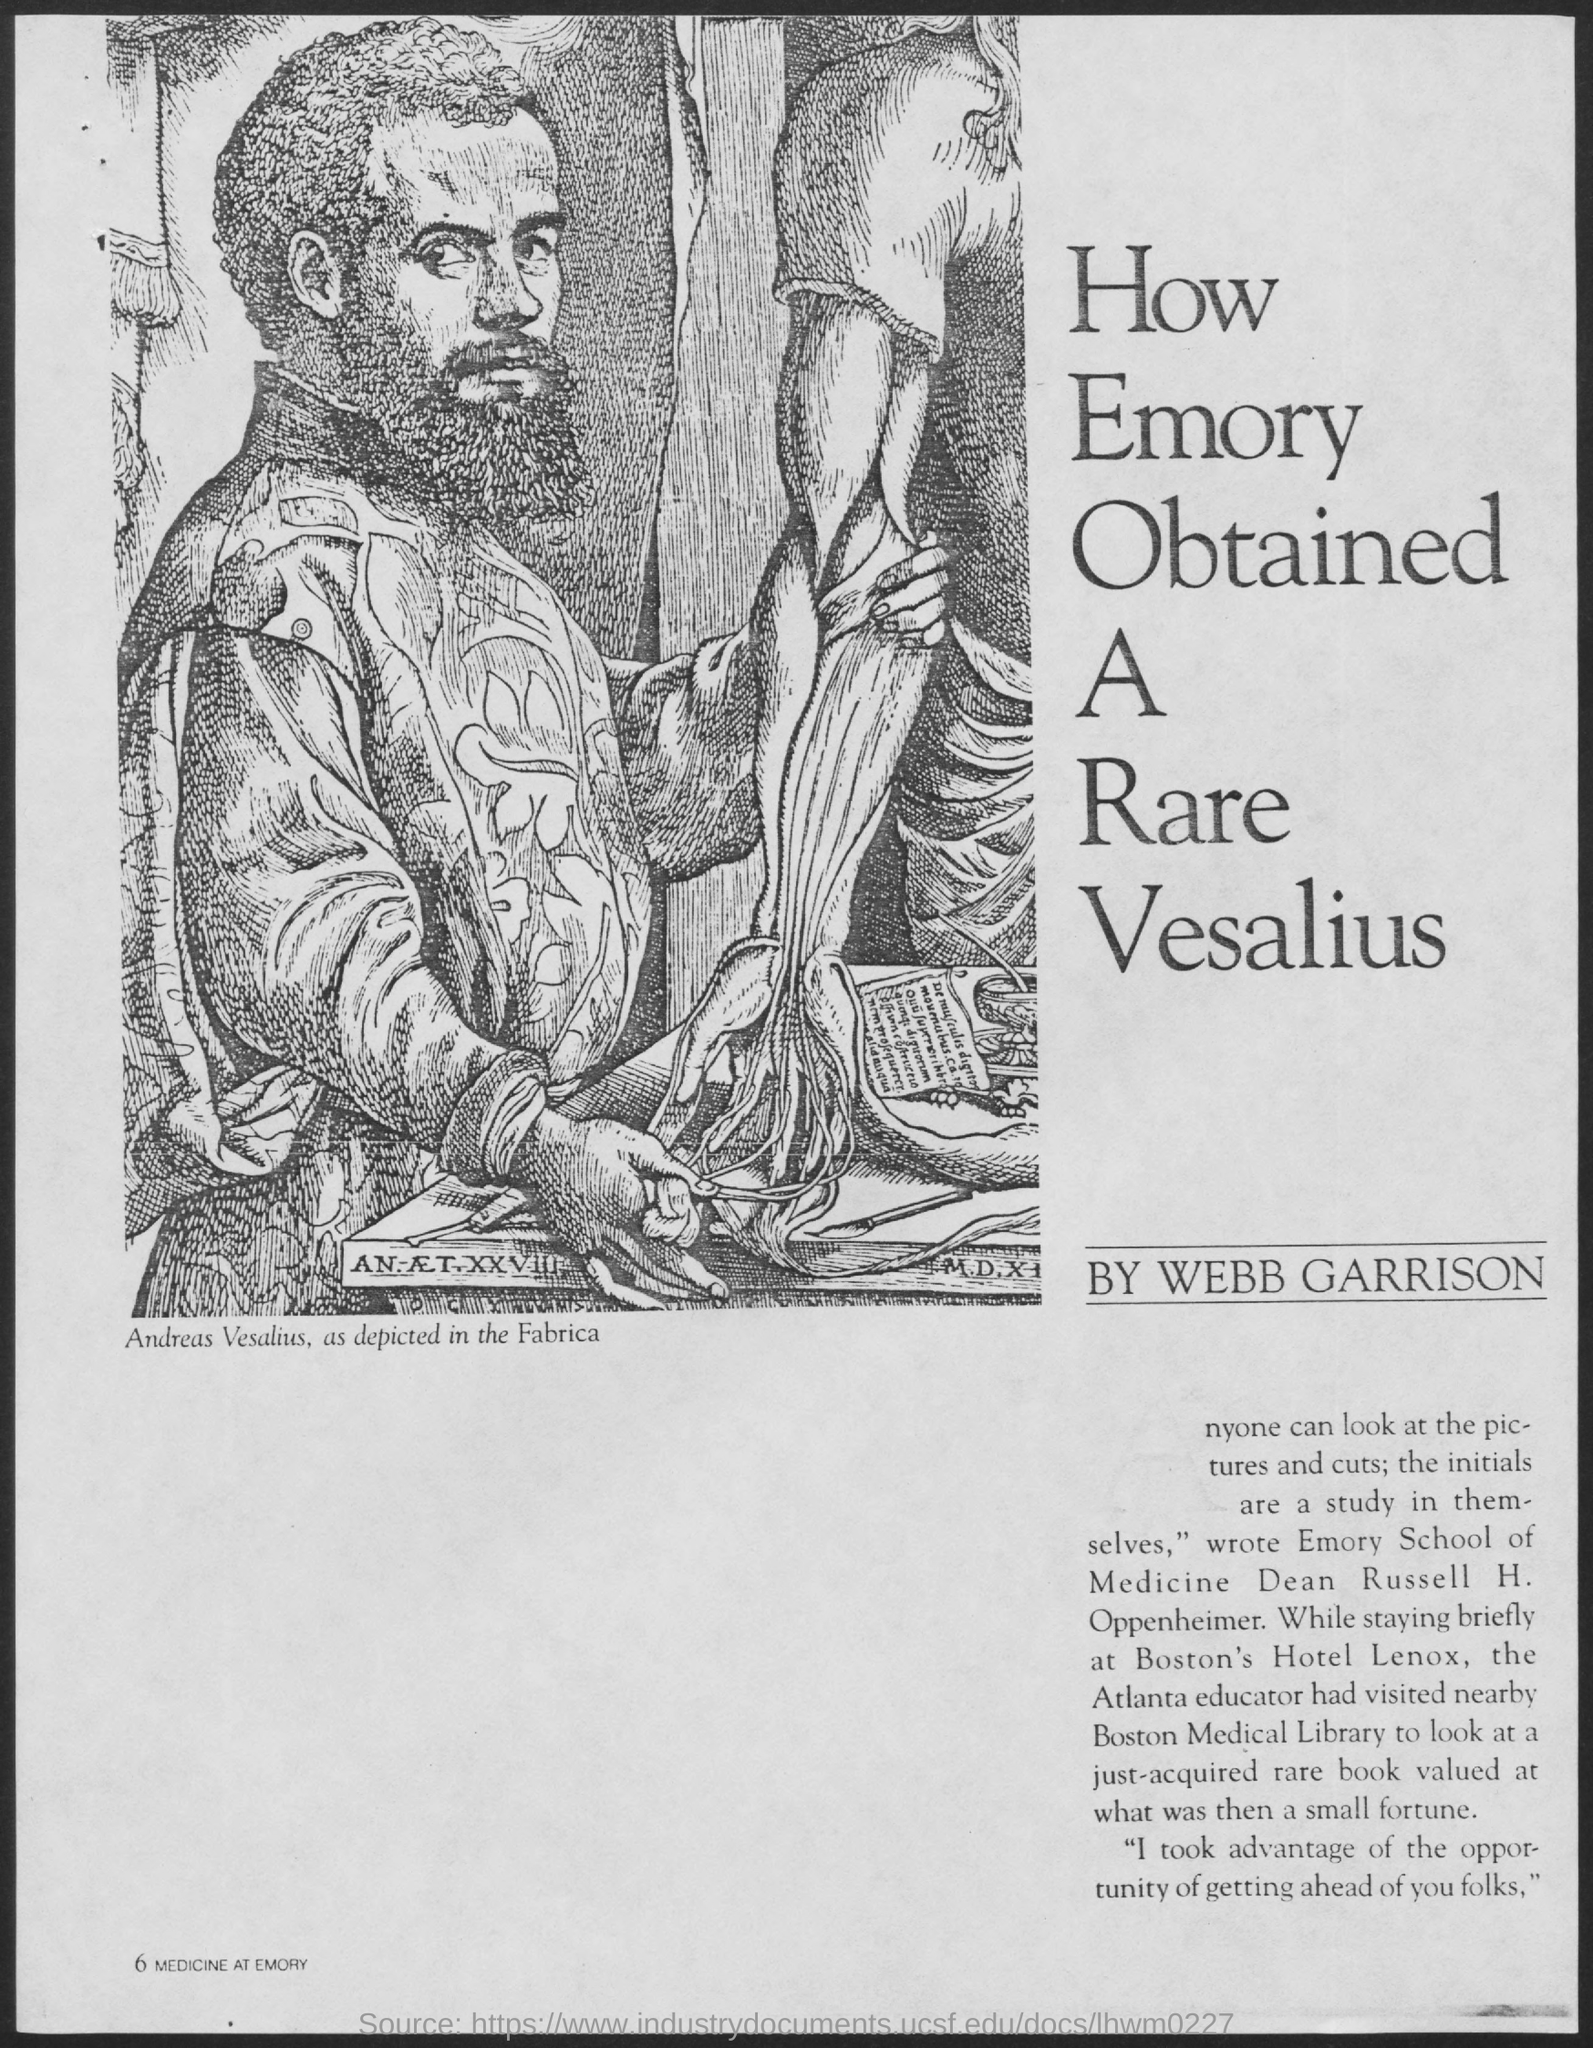Where did Russell visit while he stayed in Boston's Hotel Lenox? While staying at Boston's Hotel Lenox, Russell visited the Boston Medical Library. There, he admired a recently acquired rare book valued at a significant amount, highlighting his keen interest in seeking out valuable medical texts ahead of his contemporaries. 